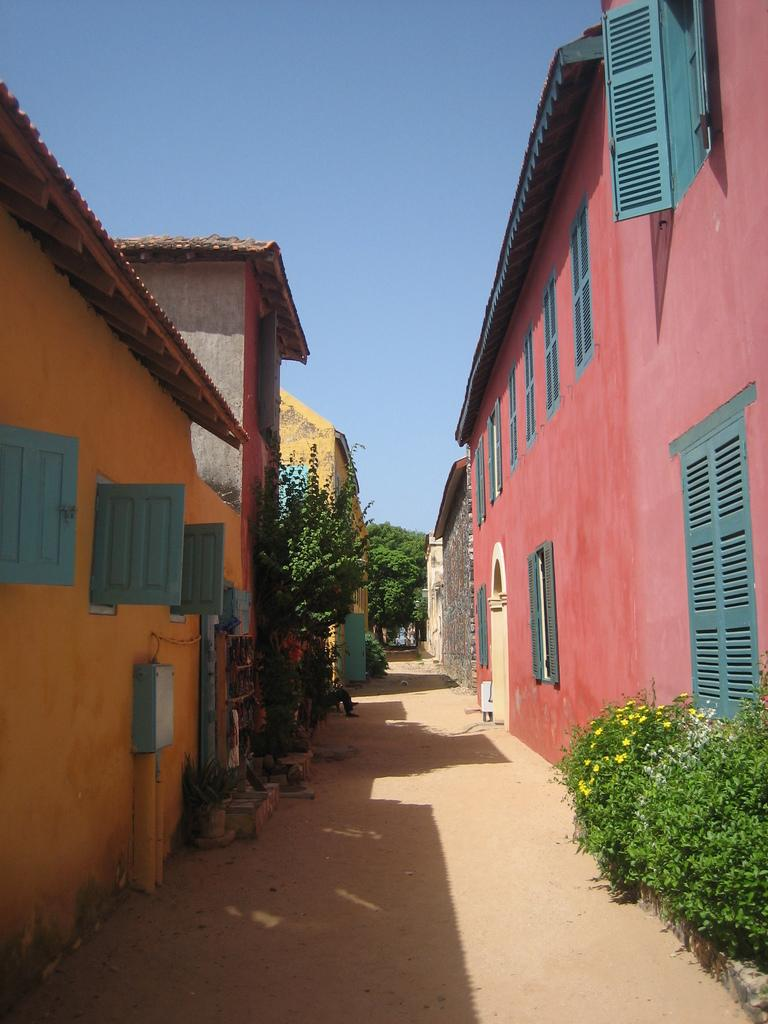What type of structures are present in the image? There are houses in the image. What features can be observed on the houses? The houses have roofs and windows. What can be seen in the image besides the houses? There is a pathway and plants visible in the image. What is visible at the top of the image? The sky is visible in the image. How deep is the quicksand in the image? There is no quicksand present in the image. What type of harmony is depicted in the image? The image does not depict any specific harmony; it features houses, a pathway, plants, and the sky. 